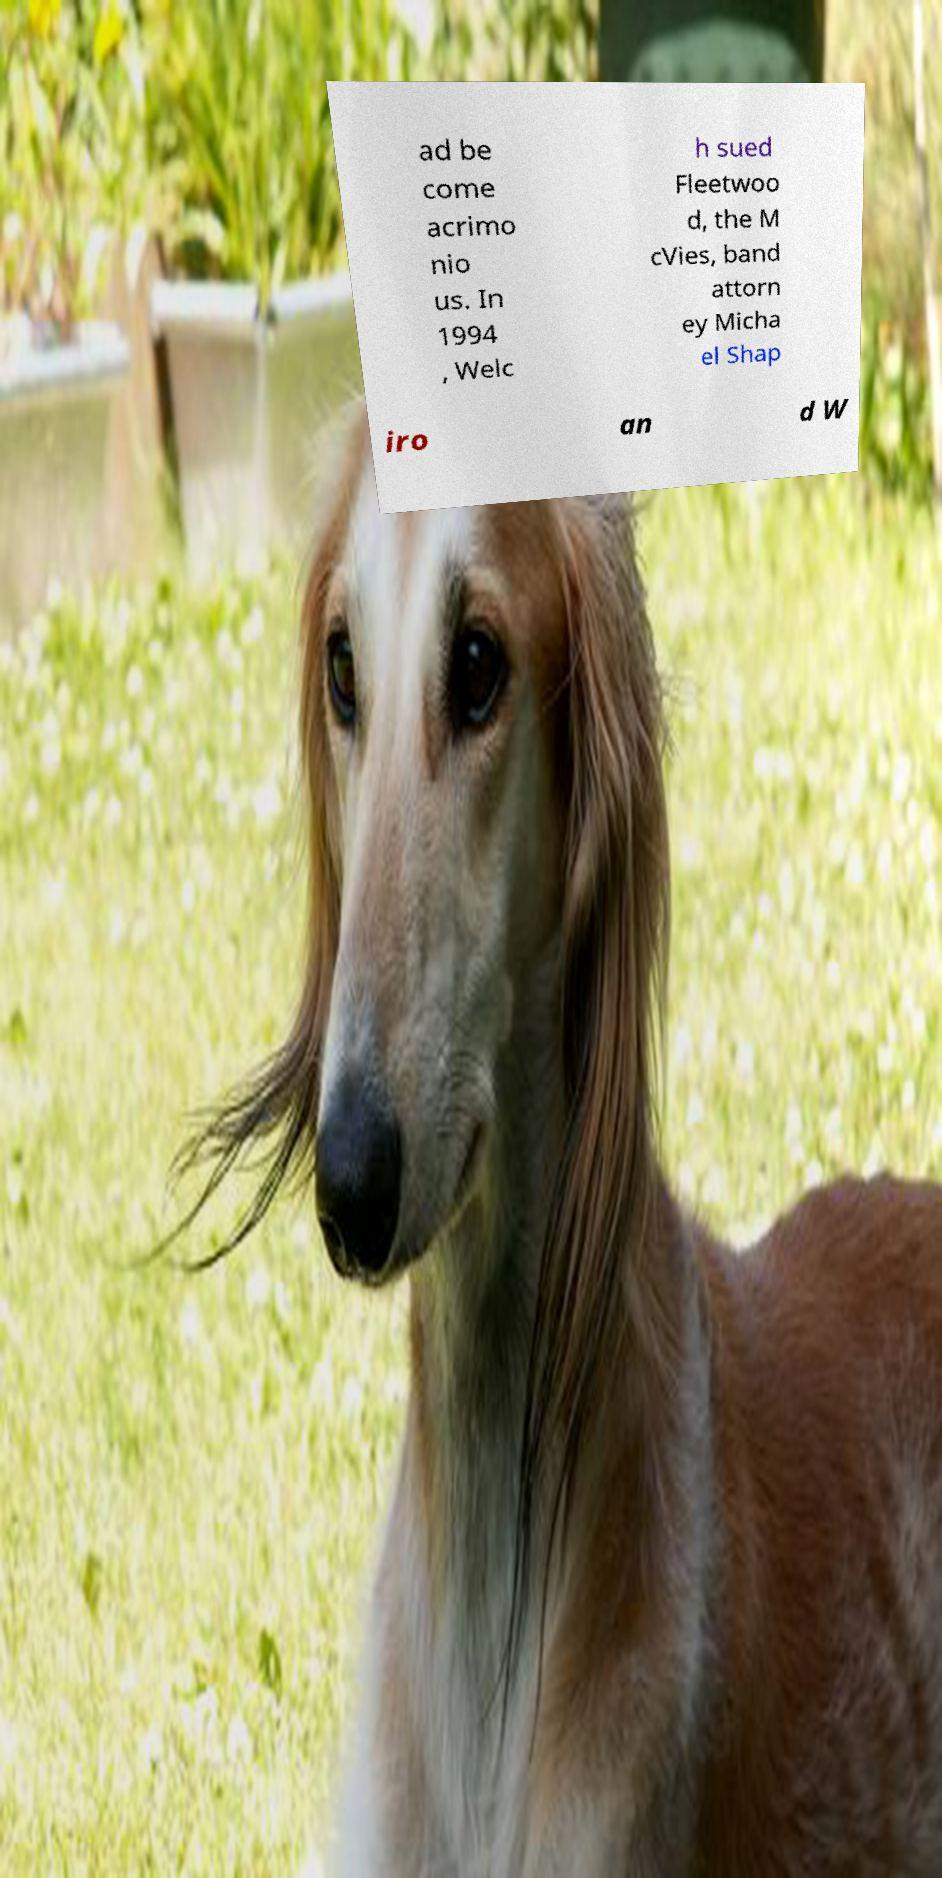Can you accurately transcribe the text from the provided image for me? ad be come acrimo nio us. In 1994 , Welc h sued Fleetwoo d, the M cVies, band attorn ey Micha el Shap iro an d W 